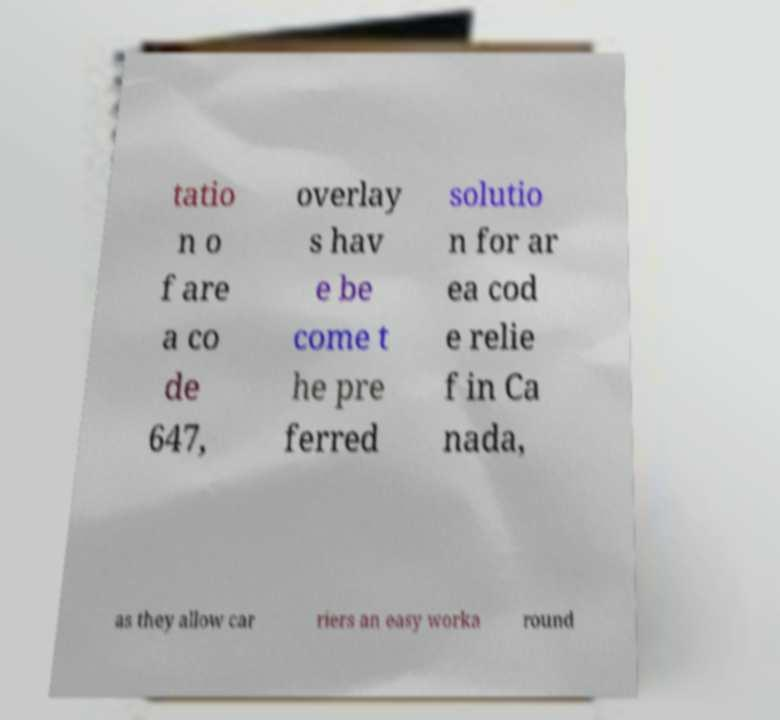I need the written content from this picture converted into text. Can you do that? tatio n o f are a co de 647, overlay s hav e be come t he pre ferred solutio n for ar ea cod e relie f in Ca nada, as they allow car riers an easy worka round 